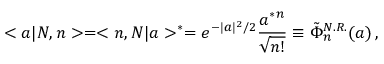<formula> <loc_0><loc_0><loc_500><loc_500>< a | N , n > = < n , N | a > ^ { * } = e ^ { - | a | ^ { 2 } / 2 } \frac { a ^ { * ^ { n } } { \sqrt { n ! } } \equiv \tilde { \Phi } _ { n } ^ { N . R . } ( a ) \, ,</formula> 